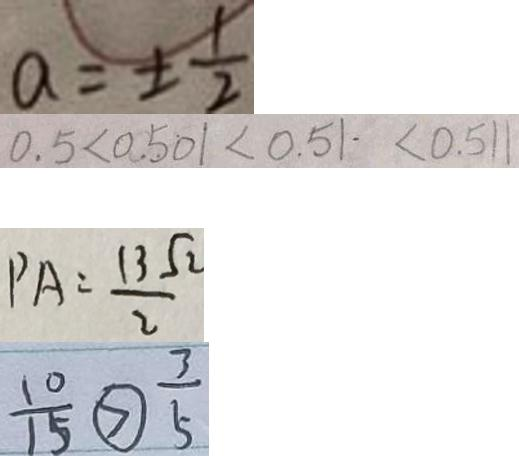<formula> <loc_0><loc_0><loc_500><loc_500>a = \pm \frac { 1 } { 2 } 
 0 . 5 < 0 . 5 0 1 < 0 . 5 1 . < 0 . 5 1 1 
 P A = \frac { 1 3 \sqrt { 2 } } { 2 } 
 \frac { 1 0 } { 1 5 } \textcircled { > } \frac { 3 } { 5 }</formula> 